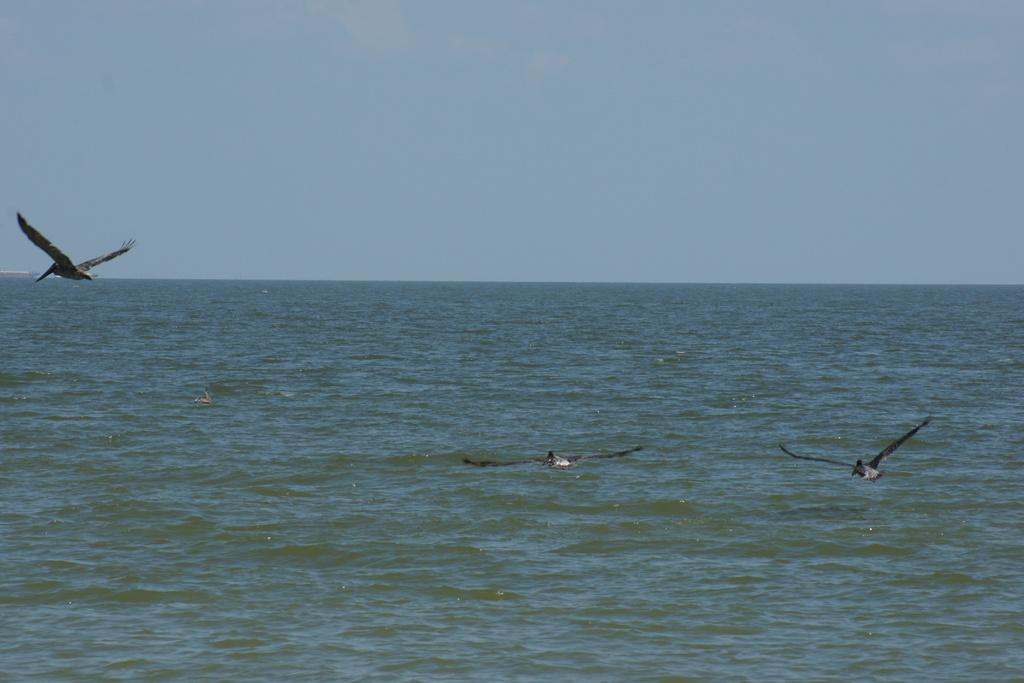What is happening in the middle of the image? There are birds flying in the image. Where are the birds located in relation to the image? The birds are in the middle of the image. What can be seen in the background of the image? There is water and the sky visible in the image. What type of humor can be seen in the book held by the tramp in the image? There is no tramp or book present in the image; it features birds flying in the middle of the image. 